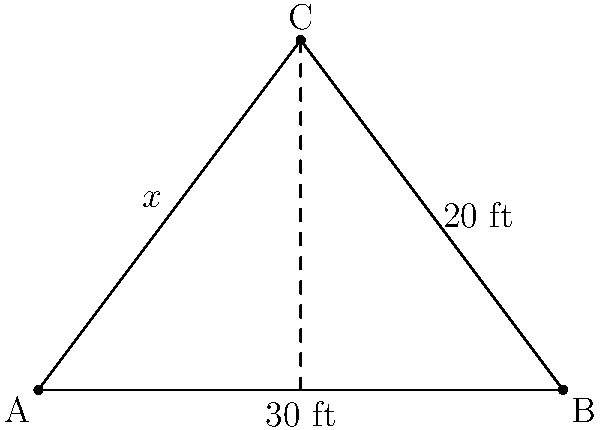In the Olentangy High School gymnasium, a basketball player is practicing shooting from different angles. The court diagram above represents a triangular section of the court. If the distance from the baseline to the shooting position is 20 feet, and the width of this section is 30 feet, what is the optimal shooting angle (represented by $x$ in the diagram) for the player to aim for the basket? Let's solve this step-by-step using the Pythagorean theorem:

1) The court diagram forms a right triangle with the following measurements:
   - Base (AB) = 30 feet
   - Height (BC) = 20 feet
   - Hypotenuse (AC) = $x$ feet (what we need to find)

2) Using the Pythagorean theorem: $a^2 + b^2 = c^2$

3) Substituting our known values:
   $30^2 + 20^2 = x^2$

4) Simplifying:
   $900 + 400 = x^2$
   $1300 = x^2$

5) Taking the square root of both sides:
   $\sqrt{1300} = x$

6) Simplifying:
   $x \approx 36.06$ feet

Therefore, the optimal shooting angle (hypotenuse of the triangle) is approximately 36.06 feet from the corner of the baseline.
Answer: $36.06$ feet 